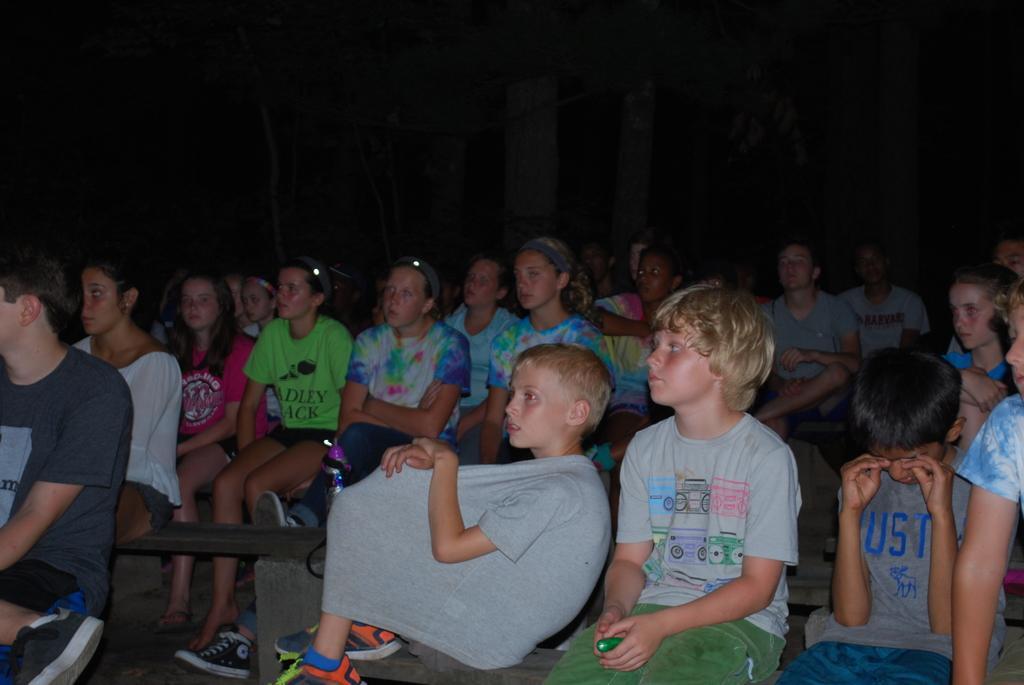Please provide a concise description of this image. Here in this picture we can see a group of children and people sitting on benches and watching something. 